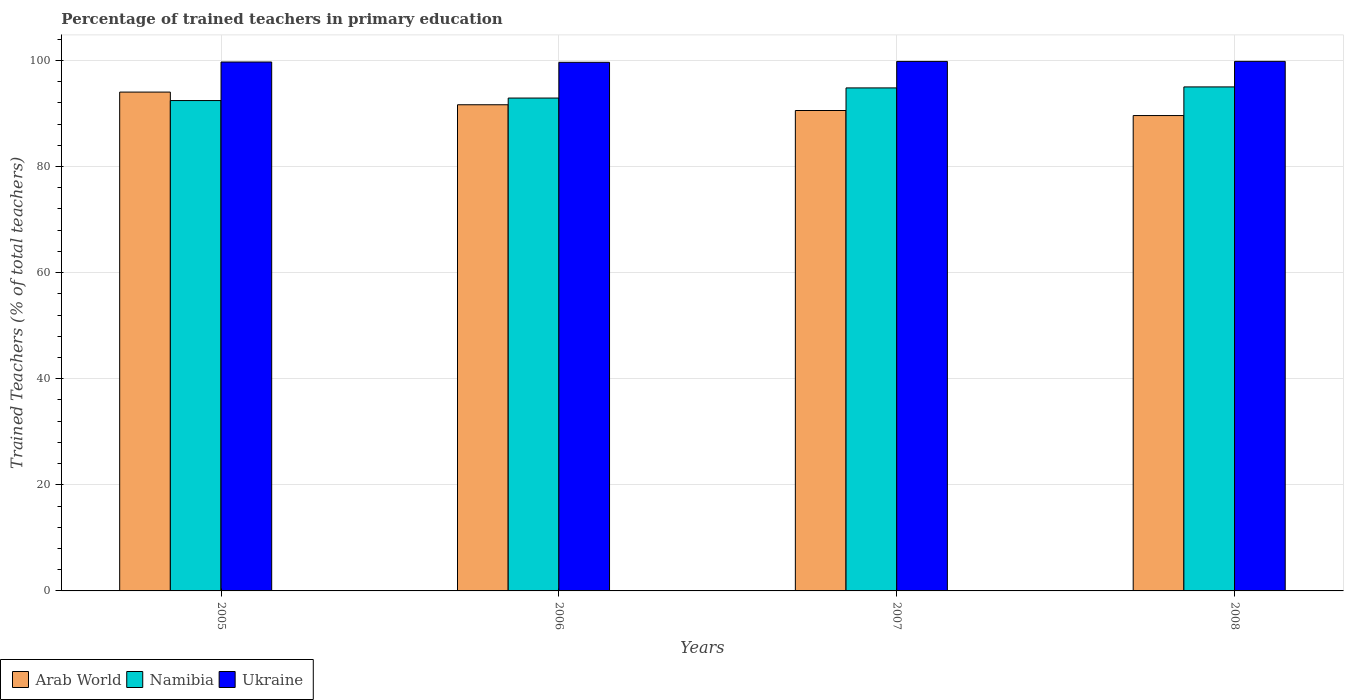Are the number of bars per tick equal to the number of legend labels?
Ensure brevity in your answer.  Yes. Are the number of bars on each tick of the X-axis equal?
Give a very brief answer. Yes. How many bars are there on the 3rd tick from the right?
Give a very brief answer. 3. What is the label of the 3rd group of bars from the left?
Your answer should be compact. 2007. In how many cases, is the number of bars for a given year not equal to the number of legend labels?
Provide a short and direct response. 0. What is the percentage of trained teachers in Arab World in 2005?
Your response must be concise. 94.02. Across all years, what is the maximum percentage of trained teachers in Arab World?
Your answer should be very brief. 94.02. Across all years, what is the minimum percentage of trained teachers in Namibia?
Make the answer very short. 92.43. In which year was the percentage of trained teachers in Ukraine maximum?
Make the answer very short. 2008. In which year was the percentage of trained teachers in Ukraine minimum?
Give a very brief answer. 2006. What is the total percentage of trained teachers in Arab World in the graph?
Make the answer very short. 365.81. What is the difference between the percentage of trained teachers in Arab World in 2005 and that in 2006?
Your answer should be very brief. 2.39. What is the difference between the percentage of trained teachers in Arab World in 2005 and the percentage of trained teachers in Ukraine in 2006?
Offer a terse response. -5.61. What is the average percentage of trained teachers in Namibia per year?
Your answer should be very brief. 93.78. In the year 2006, what is the difference between the percentage of trained teachers in Arab World and percentage of trained teachers in Ukraine?
Your answer should be compact. -8. In how many years, is the percentage of trained teachers in Namibia greater than 52 %?
Make the answer very short. 4. What is the ratio of the percentage of trained teachers in Arab World in 2005 to that in 2007?
Offer a terse response. 1.04. Is the percentage of trained teachers in Arab World in 2005 less than that in 2006?
Offer a terse response. No. Is the difference between the percentage of trained teachers in Arab World in 2005 and 2008 greater than the difference between the percentage of trained teachers in Ukraine in 2005 and 2008?
Your answer should be very brief. Yes. What is the difference between the highest and the second highest percentage of trained teachers in Arab World?
Ensure brevity in your answer.  2.39. What is the difference between the highest and the lowest percentage of trained teachers in Arab World?
Provide a succinct answer. 4.42. In how many years, is the percentage of trained teachers in Namibia greater than the average percentage of trained teachers in Namibia taken over all years?
Make the answer very short. 2. What does the 3rd bar from the left in 2005 represents?
Provide a short and direct response. Ukraine. What does the 3rd bar from the right in 2005 represents?
Give a very brief answer. Arab World. What is the difference between two consecutive major ticks on the Y-axis?
Your answer should be compact. 20. Are the values on the major ticks of Y-axis written in scientific E-notation?
Keep it short and to the point. No. Where does the legend appear in the graph?
Keep it short and to the point. Bottom left. How many legend labels are there?
Offer a very short reply. 3. How are the legend labels stacked?
Offer a terse response. Horizontal. What is the title of the graph?
Ensure brevity in your answer.  Percentage of trained teachers in primary education. What is the label or title of the Y-axis?
Ensure brevity in your answer.  Trained Teachers (% of total teachers). What is the Trained Teachers (% of total teachers) in Arab World in 2005?
Your answer should be compact. 94.02. What is the Trained Teachers (% of total teachers) of Namibia in 2005?
Give a very brief answer. 92.43. What is the Trained Teachers (% of total teachers) of Ukraine in 2005?
Your answer should be compact. 99.69. What is the Trained Teachers (% of total teachers) in Arab World in 2006?
Make the answer very short. 91.63. What is the Trained Teachers (% of total teachers) of Namibia in 2006?
Ensure brevity in your answer.  92.9. What is the Trained Teachers (% of total teachers) of Ukraine in 2006?
Your response must be concise. 99.63. What is the Trained Teachers (% of total teachers) of Arab World in 2007?
Give a very brief answer. 90.55. What is the Trained Teachers (% of total teachers) in Namibia in 2007?
Give a very brief answer. 94.81. What is the Trained Teachers (% of total teachers) of Ukraine in 2007?
Keep it short and to the point. 99.8. What is the Trained Teachers (% of total teachers) of Arab World in 2008?
Offer a very short reply. 89.6. What is the Trained Teachers (% of total teachers) of Namibia in 2008?
Your answer should be very brief. 95. What is the Trained Teachers (% of total teachers) in Ukraine in 2008?
Your response must be concise. 99.82. Across all years, what is the maximum Trained Teachers (% of total teachers) in Arab World?
Keep it short and to the point. 94.02. Across all years, what is the maximum Trained Teachers (% of total teachers) of Namibia?
Provide a succinct answer. 95. Across all years, what is the maximum Trained Teachers (% of total teachers) in Ukraine?
Provide a succinct answer. 99.82. Across all years, what is the minimum Trained Teachers (% of total teachers) of Arab World?
Keep it short and to the point. 89.6. Across all years, what is the minimum Trained Teachers (% of total teachers) in Namibia?
Your answer should be compact. 92.43. Across all years, what is the minimum Trained Teachers (% of total teachers) of Ukraine?
Ensure brevity in your answer.  99.63. What is the total Trained Teachers (% of total teachers) in Arab World in the graph?
Offer a terse response. 365.81. What is the total Trained Teachers (% of total teachers) of Namibia in the graph?
Provide a succinct answer. 375.13. What is the total Trained Teachers (% of total teachers) of Ukraine in the graph?
Keep it short and to the point. 398.94. What is the difference between the Trained Teachers (% of total teachers) in Arab World in 2005 and that in 2006?
Your response must be concise. 2.39. What is the difference between the Trained Teachers (% of total teachers) in Namibia in 2005 and that in 2006?
Give a very brief answer. -0.47. What is the difference between the Trained Teachers (% of total teachers) in Ukraine in 2005 and that in 2006?
Offer a terse response. 0.06. What is the difference between the Trained Teachers (% of total teachers) in Arab World in 2005 and that in 2007?
Offer a very short reply. 3.47. What is the difference between the Trained Teachers (% of total teachers) in Namibia in 2005 and that in 2007?
Offer a very short reply. -2.38. What is the difference between the Trained Teachers (% of total teachers) in Ukraine in 2005 and that in 2007?
Provide a succinct answer. -0.11. What is the difference between the Trained Teachers (% of total teachers) in Arab World in 2005 and that in 2008?
Keep it short and to the point. 4.42. What is the difference between the Trained Teachers (% of total teachers) of Namibia in 2005 and that in 2008?
Keep it short and to the point. -2.57. What is the difference between the Trained Teachers (% of total teachers) of Ukraine in 2005 and that in 2008?
Your response must be concise. -0.12. What is the difference between the Trained Teachers (% of total teachers) of Arab World in 2006 and that in 2007?
Offer a terse response. 1.08. What is the difference between the Trained Teachers (% of total teachers) in Namibia in 2006 and that in 2007?
Offer a very short reply. -1.91. What is the difference between the Trained Teachers (% of total teachers) in Ukraine in 2006 and that in 2007?
Your answer should be very brief. -0.17. What is the difference between the Trained Teachers (% of total teachers) in Arab World in 2006 and that in 2008?
Ensure brevity in your answer.  2.04. What is the difference between the Trained Teachers (% of total teachers) in Namibia in 2006 and that in 2008?
Give a very brief answer. -2.1. What is the difference between the Trained Teachers (% of total teachers) of Ukraine in 2006 and that in 2008?
Offer a very short reply. -0.18. What is the difference between the Trained Teachers (% of total teachers) in Arab World in 2007 and that in 2008?
Keep it short and to the point. 0.95. What is the difference between the Trained Teachers (% of total teachers) of Namibia in 2007 and that in 2008?
Offer a very short reply. -0.19. What is the difference between the Trained Teachers (% of total teachers) in Ukraine in 2007 and that in 2008?
Ensure brevity in your answer.  -0.01. What is the difference between the Trained Teachers (% of total teachers) in Arab World in 2005 and the Trained Teachers (% of total teachers) in Namibia in 2006?
Your answer should be compact. 1.12. What is the difference between the Trained Teachers (% of total teachers) in Arab World in 2005 and the Trained Teachers (% of total teachers) in Ukraine in 2006?
Make the answer very short. -5.61. What is the difference between the Trained Teachers (% of total teachers) of Namibia in 2005 and the Trained Teachers (% of total teachers) of Ukraine in 2006?
Your response must be concise. -7.21. What is the difference between the Trained Teachers (% of total teachers) in Arab World in 2005 and the Trained Teachers (% of total teachers) in Namibia in 2007?
Keep it short and to the point. -0.79. What is the difference between the Trained Teachers (% of total teachers) of Arab World in 2005 and the Trained Teachers (% of total teachers) of Ukraine in 2007?
Your answer should be compact. -5.78. What is the difference between the Trained Teachers (% of total teachers) of Namibia in 2005 and the Trained Teachers (% of total teachers) of Ukraine in 2007?
Provide a short and direct response. -7.38. What is the difference between the Trained Teachers (% of total teachers) of Arab World in 2005 and the Trained Teachers (% of total teachers) of Namibia in 2008?
Keep it short and to the point. -0.98. What is the difference between the Trained Teachers (% of total teachers) of Arab World in 2005 and the Trained Teachers (% of total teachers) of Ukraine in 2008?
Your answer should be very brief. -5.79. What is the difference between the Trained Teachers (% of total teachers) of Namibia in 2005 and the Trained Teachers (% of total teachers) of Ukraine in 2008?
Keep it short and to the point. -7.39. What is the difference between the Trained Teachers (% of total teachers) in Arab World in 2006 and the Trained Teachers (% of total teachers) in Namibia in 2007?
Provide a short and direct response. -3.17. What is the difference between the Trained Teachers (% of total teachers) in Arab World in 2006 and the Trained Teachers (% of total teachers) in Ukraine in 2007?
Your answer should be very brief. -8.17. What is the difference between the Trained Teachers (% of total teachers) in Namibia in 2006 and the Trained Teachers (% of total teachers) in Ukraine in 2007?
Give a very brief answer. -6.9. What is the difference between the Trained Teachers (% of total teachers) in Arab World in 2006 and the Trained Teachers (% of total teachers) in Namibia in 2008?
Keep it short and to the point. -3.36. What is the difference between the Trained Teachers (% of total teachers) of Arab World in 2006 and the Trained Teachers (% of total teachers) of Ukraine in 2008?
Your answer should be very brief. -8.18. What is the difference between the Trained Teachers (% of total teachers) of Namibia in 2006 and the Trained Teachers (% of total teachers) of Ukraine in 2008?
Provide a short and direct response. -6.92. What is the difference between the Trained Teachers (% of total teachers) of Arab World in 2007 and the Trained Teachers (% of total teachers) of Namibia in 2008?
Ensure brevity in your answer.  -4.45. What is the difference between the Trained Teachers (% of total teachers) in Arab World in 2007 and the Trained Teachers (% of total teachers) in Ukraine in 2008?
Offer a very short reply. -9.26. What is the difference between the Trained Teachers (% of total teachers) in Namibia in 2007 and the Trained Teachers (% of total teachers) in Ukraine in 2008?
Make the answer very short. -5.01. What is the average Trained Teachers (% of total teachers) of Arab World per year?
Keep it short and to the point. 91.45. What is the average Trained Teachers (% of total teachers) in Namibia per year?
Offer a very short reply. 93.78. What is the average Trained Teachers (% of total teachers) in Ukraine per year?
Make the answer very short. 99.74. In the year 2005, what is the difference between the Trained Teachers (% of total teachers) of Arab World and Trained Teachers (% of total teachers) of Namibia?
Your answer should be compact. 1.59. In the year 2005, what is the difference between the Trained Teachers (% of total teachers) in Arab World and Trained Teachers (% of total teachers) in Ukraine?
Ensure brevity in your answer.  -5.67. In the year 2005, what is the difference between the Trained Teachers (% of total teachers) of Namibia and Trained Teachers (% of total teachers) of Ukraine?
Give a very brief answer. -7.26. In the year 2006, what is the difference between the Trained Teachers (% of total teachers) of Arab World and Trained Teachers (% of total teachers) of Namibia?
Your response must be concise. -1.26. In the year 2006, what is the difference between the Trained Teachers (% of total teachers) in Arab World and Trained Teachers (% of total teachers) in Ukraine?
Your answer should be compact. -8. In the year 2006, what is the difference between the Trained Teachers (% of total teachers) of Namibia and Trained Teachers (% of total teachers) of Ukraine?
Make the answer very short. -6.74. In the year 2007, what is the difference between the Trained Teachers (% of total teachers) in Arab World and Trained Teachers (% of total teachers) in Namibia?
Provide a succinct answer. -4.26. In the year 2007, what is the difference between the Trained Teachers (% of total teachers) in Arab World and Trained Teachers (% of total teachers) in Ukraine?
Provide a short and direct response. -9.25. In the year 2007, what is the difference between the Trained Teachers (% of total teachers) of Namibia and Trained Teachers (% of total teachers) of Ukraine?
Your response must be concise. -4.99. In the year 2008, what is the difference between the Trained Teachers (% of total teachers) in Arab World and Trained Teachers (% of total teachers) in Namibia?
Keep it short and to the point. -5.4. In the year 2008, what is the difference between the Trained Teachers (% of total teachers) of Arab World and Trained Teachers (% of total teachers) of Ukraine?
Give a very brief answer. -10.22. In the year 2008, what is the difference between the Trained Teachers (% of total teachers) in Namibia and Trained Teachers (% of total teachers) in Ukraine?
Provide a short and direct response. -4.82. What is the ratio of the Trained Teachers (% of total teachers) of Arab World in 2005 to that in 2006?
Your response must be concise. 1.03. What is the ratio of the Trained Teachers (% of total teachers) of Arab World in 2005 to that in 2007?
Keep it short and to the point. 1.04. What is the ratio of the Trained Teachers (% of total teachers) in Namibia in 2005 to that in 2007?
Keep it short and to the point. 0.97. What is the ratio of the Trained Teachers (% of total teachers) of Ukraine in 2005 to that in 2007?
Keep it short and to the point. 1. What is the ratio of the Trained Teachers (% of total teachers) in Arab World in 2005 to that in 2008?
Offer a terse response. 1.05. What is the ratio of the Trained Teachers (% of total teachers) in Namibia in 2005 to that in 2008?
Your answer should be compact. 0.97. What is the ratio of the Trained Teachers (% of total teachers) in Arab World in 2006 to that in 2007?
Keep it short and to the point. 1.01. What is the ratio of the Trained Teachers (% of total teachers) in Namibia in 2006 to that in 2007?
Make the answer very short. 0.98. What is the ratio of the Trained Teachers (% of total teachers) of Ukraine in 2006 to that in 2007?
Your answer should be compact. 1. What is the ratio of the Trained Teachers (% of total teachers) of Arab World in 2006 to that in 2008?
Give a very brief answer. 1.02. What is the ratio of the Trained Teachers (% of total teachers) of Namibia in 2006 to that in 2008?
Keep it short and to the point. 0.98. What is the ratio of the Trained Teachers (% of total teachers) in Ukraine in 2006 to that in 2008?
Your response must be concise. 1. What is the ratio of the Trained Teachers (% of total teachers) in Arab World in 2007 to that in 2008?
Provide a short and direct response. 1.01. What is the ratio of the Trained Teachers (% of total teachers) of Namibia in 2007 to that in 2008?
Offer a very short reply. 1. What is the ratio of the Trained Teachers (% of total teachers) in Ukraine in 2007 to that in 2008?
Give a very brief answer. 1. What is the difference between the highest and the second highest Trained Teachers (% of total teachers) in Arab World?
Your answer should be very brief. 2.39. What is the difference between the highest and the second highest Trained Teachers (% of total teachers) in Namibia?
Make the answer very short. 0.19. What is the difference between the highest and the second highest Trained Teachers (% of total teachers) of Ukraine?
Make the answer very short. 0.01. What is the difference between the highest and the lowest Trained Teachers (% of total teachers) of Arab World?
Provide a short and direct response. 4.42. What is the difference between the highest and the lowest Trained Teachers (% of total teachers) in Namibia?
Offer a very short reply. 2.57. What is the difference between the highest and the lowest Trained Teachers (% of total teachers) in Ukraine?
Offer a very short reply. 0.18. 